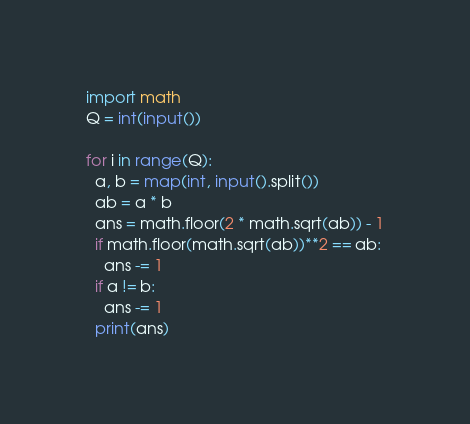<code> <loc_0><loc_0><loc_500><loc_500><_Python_>import math
Q = int(input())

for i in range(Q):
  a, b = map(int, input().split())
  ab = a * b
  ans = math.floor(2 * math.sqrt(ab)) - 1
  if math.floor(math.sqrt(ab))**2 == ab:
    ans -= 1
  if a != b:
    ans -= 1
  print(ans)</code> 